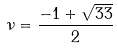Convert formula to latex. <formula><loc_0><loc_0><loc_500><loc_500>\nu = \frac { - 1 + \sqrt { 3 3 } } { 2 }</formula> 